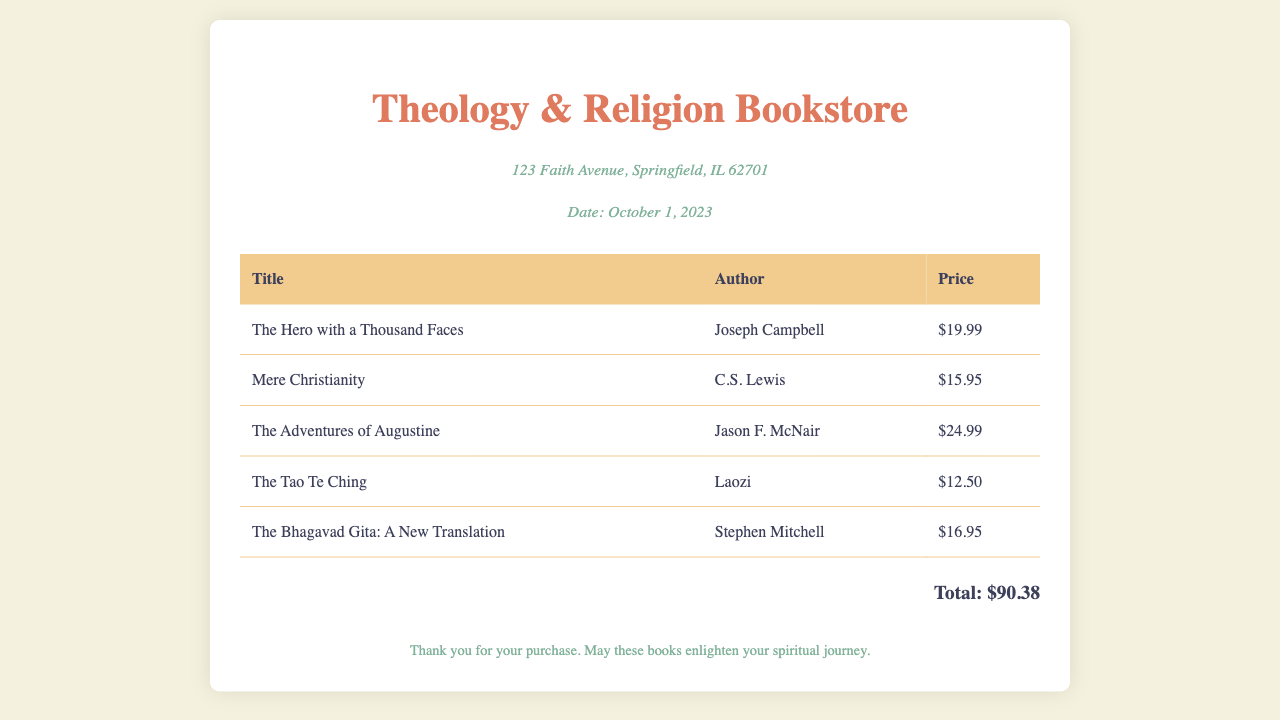What is the name of the bookstore? The name of the bookstore is specified in the header section of the document.
Answer: Theology & Religion Bookstore Who is the author of "Mere Christianity"? The author of "Mere Christianity" is listed next to the book title in the table.
Answer: C.S. Lewis What is the price of "The Hero with a Thousand Faces"? The price is shown in the corresponding row of the table under the "Price" column for that book title.
Answer: $19.99 What is the total cost of the books purchased? The total cost is provided in the footer section as the sum of all book prices.
Answer: $90.38 What date was the invoice issued? The date is indicated in the header section of the invoice.
Answer: October 1, 2023 How many books are listed in the invoice? The total count of books can be determined by counting the rows in the book table.
Answer: 5 Which book was written by Stephen Mitchell? This requires identifying the author and title from the book list in the table.
Answer: The Bhagavad Gita: A New Translation What is the address of the bookstore? The address is given in the header section below the bookstore name.
Answer: 123 Faith Avenue, Springfield, IL 62701 What message is included in the footer of the invoice? The footer contains a note thanking the customer and wishing them well.
Answer: Thank you for your purchase. May these books enlighten your spiritual journey 